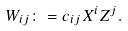Convert formula to latex. <formula><loc_0><loc_0><loc_500><loc_500>W _ { i j } \colon = c _ { i j } X ^ { i } Z ^ { j } .</formula> 